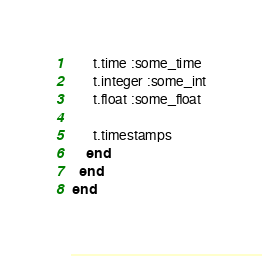<code> <loc_0><loc_0><loc_500><loc_500><_Ruby_>      t.time :some_time
      t.integer :some_int
      t.float :some_float

      t.timestamps
    end
  end
end
</code> 